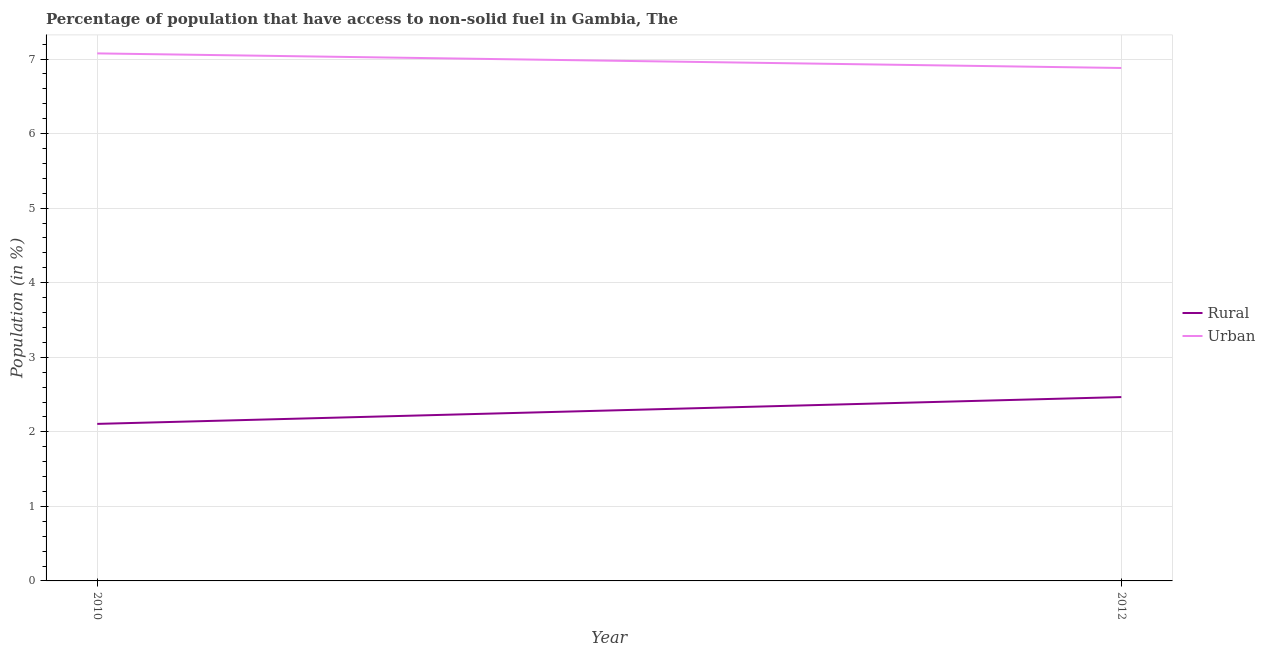How many different coloured lines are there?
Your answer should be very brief. 2. Does the line corresponding to rural population intersect with the line corresponding to urban population?
Keep it short and to the point. No. Is the number of lines equal to the number of legend labels?
Make the answer very short. Yes. What is the urban population in 2010?
Make the answer very short. 7.08. Across all years, what is the maximum urban population?
Your answer should be very brief. 7.08. Across all years, what is the minimum urban population?
Offer a very short reply. 6.88. What is the total rural population in the graph?
Your answer should be compact. 4.57. What is the difference between the urban population in 2010 and that in 2012?
Provide a succinct answer. 0.2. What is the difference between the urban population in 2012 and the rural population in 2010?
Offer a very short reply. 4.77. What is the average rural population per year?
Provide a short and direct response. 2.29. In the year 2012, what is the difference between the rural population and urban population?
Give a very brief answer. -4.41. What is the ratio of the urban population in 2010 to that in 2012?
Provide a short and direct response. 1.03. In how many years, is the rural population greater than the average rural population taken over all years?
Your response must be concise. 1. How many lines are there?
Provide a short and direct response. 2. What is the difference between two consecutive major ticks on the Y-axis?
Make the answer very short. 1. Are the values on the major ticks of Y-axis written in scientific E-notation?
Offer a terse response. No. Does the graph contain any zero values?
Offer a very short reply. No. Where does the legend appear in the graph?
Your answer should be compact. Center right. How are the legend labels stacked?
Your response must be concise. Vertical. What is the title of the graph?
Keep it short and to the point. Percentage of population that have access to non-solid fuel in Gambia, The. What is the label or title of the Y-axis?
Ensure brevity in your answer.  Population (in %). What is the Population (in %) of Rural in 2010?
Ensure brevity in your answer.  2.11. What is the Population (in %) in Urban in 2010?
Ensure brevity in your answer.  7.08. What is the Population (in %) of Rural in 2012?
Your answer should be compact. 2.47. What is the Population (in %) of Urban in 2012?
Provide a short and direct response. 6.88. Across all years, what is the maximum Population (in %) of Rural?
Your answer should be compact. 2.47. Across all years, what is the maximum Population (in %) of Urban?
Provide a short and direct response. 7.08. Across all years, what is the minimum Population (in %) of Rural?
Your response must be concise. 2.11. Across all years, what is the minimum Population (in %) of Urban?
Provide a short and direct response. 6.88. What is the total Population (in %) of Rural in the graph?
Your answer should be compact. 4.57. What is the total Population (in %) in Urban in the graph?
Offer a very short reply. 13.96. What is the difference between the Population (in %) in Rural in 2010 and that in 2012?
Your answer should be very brief. -0.36. What is the difference between the Population (in %) of Urban in 2010 and that in 2012?
Give a very brief answer. 0.2. What is the difference between the Population (in %) of Rural in 2010 and the Population (in %) of Urban in 2012?
Offer a very short reply. -4.77. What is the average Population (in %) in Rural per year?
Offer a terse response. 2.29. What is the average Population (in %) in Urban per year?
Your response must be concise. 6.98. In the year 2010, what is the difference between the Population (in %) of Rural and Population (in %) of Urban?
Provide a short and direct response. -4.97. In the year 2012, what is the difference between the Population (in %) in Rural and Population (in %) in Urban?
Offer a very short reply. -4.41. What is the ratio of the Population (in %) in Rural in 2010 to that in 2012?
Your response must be concise. 0.85. What is the ratio of the Population (in %) of Urban in 2010 to that in 2012?
Give a very brief answer. 1.03. What is the difference between the highest and the second highest Population (in %) of Rural?
Offer a terse response. 0.36. What is the difference between the highest and the second highest Population (in %) in Urban?
Offer a terse response. 0.2. What is the difference between the highest and the lowest Population (in %) of Rural?
Ensure brevity in your answer.  0.36. What is the difference between the highest and the lowest Population (in %) of Urban?
Offer a terse response. 0.2. 